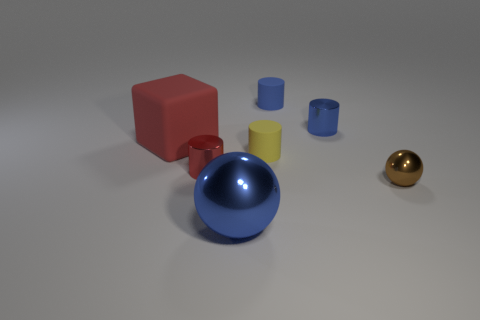How many shiny things are small red things or tiny things?
Your answer should be compact. 3. Are there fewer tiny brown metal balls that are on the left side of the big blue metal thing than tiny blue matte cylinders that are behind the brown ball?
Your response must be concise. Yes. Are there any large spheres that are in front of the cylinder that is to the right of the tiny blue cylinder that is left of the tiny blue metallic cylinder?
Your answer should be compact. Yes. There is a thing that is the same color as the big matte cube; what is it made of?
Your response must be concise. Metal. There is a big rubber object that is on the left side of the blue matte cylinder; is its shape the same as the small shiny object on the left side of the big blue ball?
Ensure brevity in your answer.  No. There is a red object that is the same size as the brown metallic sphere; what material is it?
Offer a very short reply. Metal. Is the large thing in front of the big red object made of the same material as the small yellow thing that is on the left side of the brown shiny ball?
Give a very brief answer. No. There is a brown shiny object that is the same size as the yellow matte cylinder; what shape is it?
Provide a short and direct response. Sphere. How many other objects are the same color as the small sphere?
Your response must be concise. 0. The cylinder that is left of the yellow rubber object is what color?
Give a very brief answer. Red. 